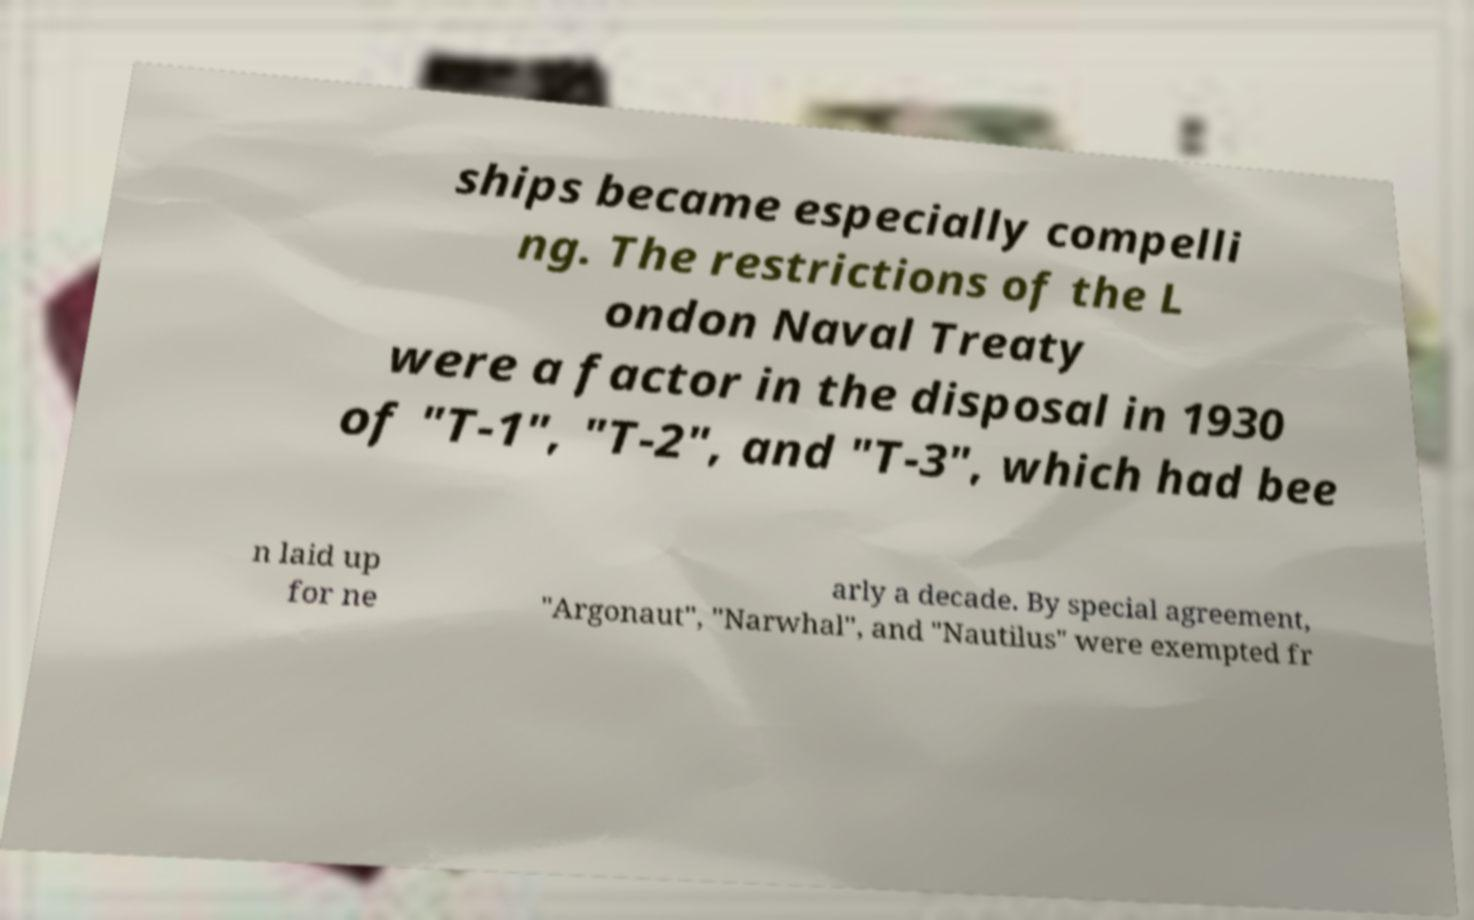I need the written content from this picture converted into text. Can you do that? ships became especially compelli ng. The restrictions of the L ondon Naval Treaty were a factor in the disposal in 1930 of "T-1", "T-2", and "T-3", which had bee n laid up for ne arly a decade. By special agreement, "Argonaut", "Narwhal", and "Nautilus" were exempted fr 